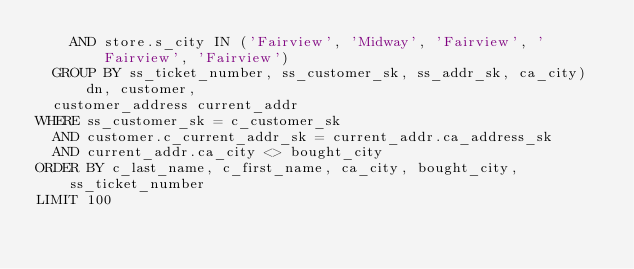Convert code to text. <code><loc_0><loc_0><loc_500><loc_500><_SQL_>    AND store.s_city IN ('Fairview', 'Midway', 'Fairview', 'Fairview', 'Fairview')
  GROUP BY ss_ticket_number, ss_customer_sk, ss_addr_sk, ca_city) dn, customer,
  customer_address current_addr
WHERE ss_customer_sk = c_customer_sk
  AND customer.c_current_addr_sk = current_addr.ca_address_sk
  AND current_addr.ca_city <> bought_city
ORDER BY c_last_name, c_first_name, ca_city, bought_city, ss_ticket_number
LIMIT 100
</code> 